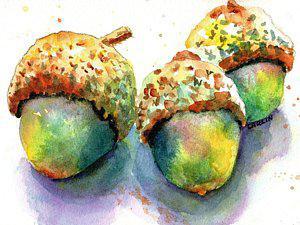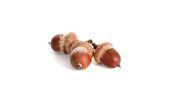The first image is the image on the left, the second image is the image on the right. Evaluate the accuracy of this statement regarding the images: "Each image shows at least two acorns and two acorn caps overlapping at least one green oak leaf.". Is it true? Answer yes or no. No. The first image is the image on the left, the second image is the image on the right. Given the left and right images, does the statement "The left and right image contains the same number of acorns." hold true? Answer yes or no. Yes. 